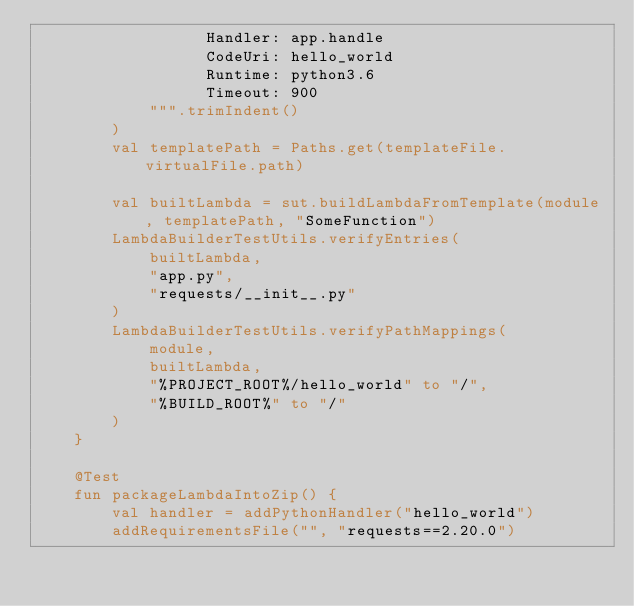<code> <loc_0><loc_0><loc_500><loc_500><_Kotlin_>                  Handler: app.handle
                  CodeUri: hello_world
                  Runtime: python3.6
                  Timeout: 900
            """.trimIndent()
        )
        val templatePath = Paths.get(templateFile.virtualFile.path)

        val builtLambda = sut.buildLambdaFromTemplate(module, templatePath, "SomeFunction")
        LambdaBuilderTestUtils.verifyEntries(
            builtLambda,
            "app.py",
            "requests/__init__.py"
        )
        LambdaBuilderTestUtils.verifyPathMappings(
            module,
            builtLambda,
            "%PROJECT_ROOT%/hello_world" to "/",
            "%BUILD_ROOT%" to "/"
        )
    }

    @Test
    fun packageLambdaIntoZip() {
        val handler = addPythonHandler("hello_world")
        addRequirementsFile("", "requests==2.20.0")
</code> 